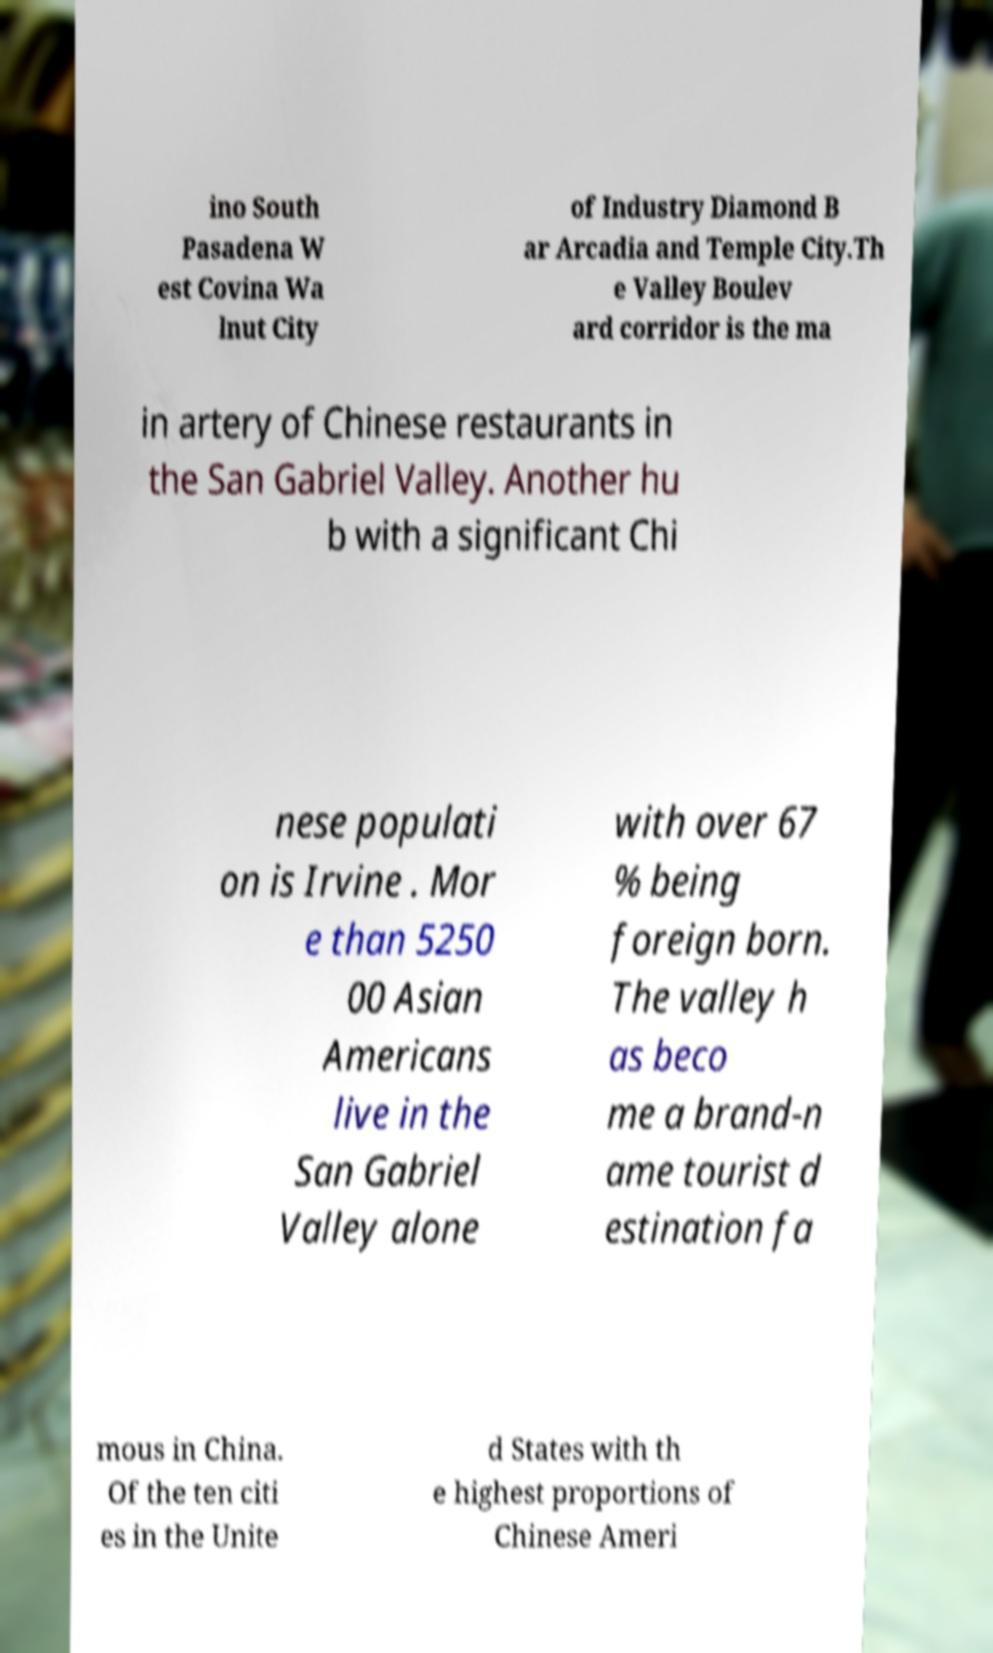Please read and relay the text visible in this image. What does it say? ino South Pasadena W est Covina Wa lnut City of Industry Diamond B ar Arcadia and Temple City.Th e Valley Boulev ard corridor is the ma in artery of Chinese restaurants in the San Gabriel Valley. Another hu b with a significant Chi nese populati on is Irvine . Mor e than 5250 00 Asian Americans live in the San Gabriel Valley alone with over 67 % being foreign born. The valley h as beco me a brand-n ame tourist d estination fa mous in China. Of the ten citi es in the Unite d States with th e highest proportions of Chinese Ameri 